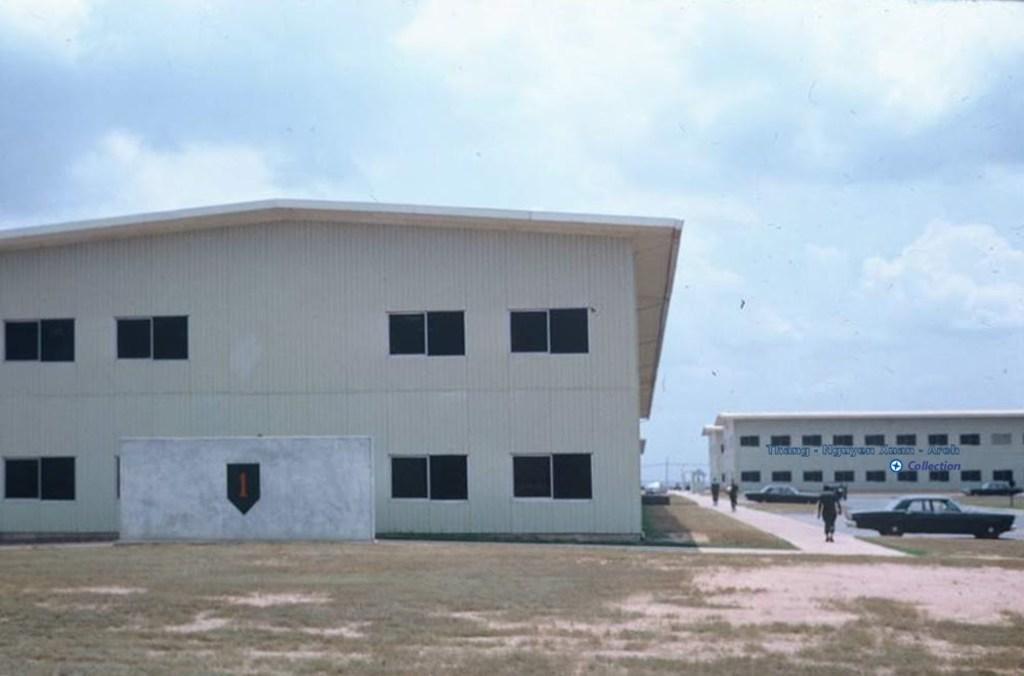Describe this image in one or two sentences. In this image there is the sky towards the top of the image, there are clouds in the sky, there is a building towards the left of the image, there is a building towards the right of the image, there is text towards the right of the image, there are three men walking, there are cars towards the right of the image, there are windows, there is a wall, there is a number on the wall, there is ground towards the bottom of the image, there is grass on the ground. 